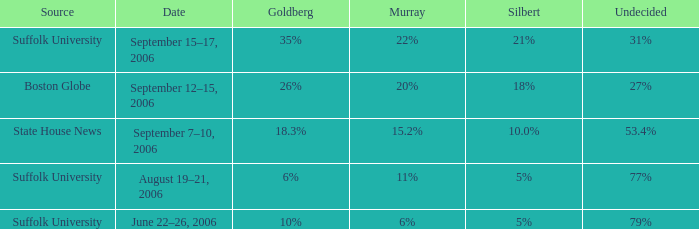What percentage of the poll is still undecided if goldberg has a 6% share? 77%. 